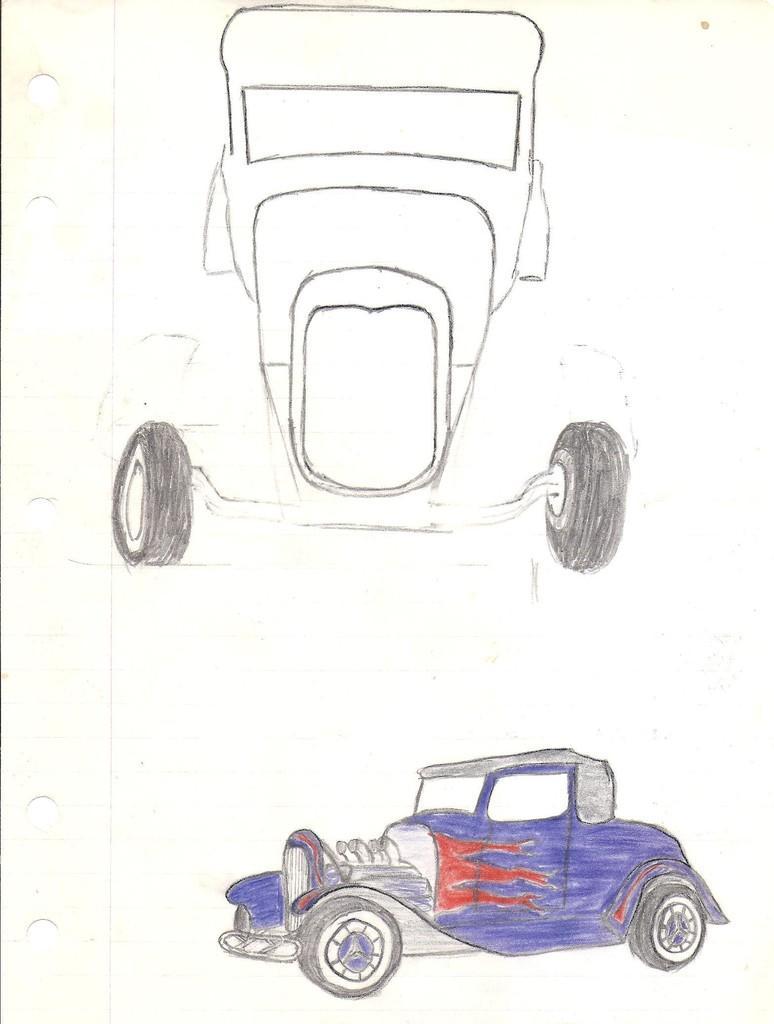Can you describe this image briefly? In the center of the image we can see one paper. On the paper, we can see some drawing, in which we can see vehicles. And we can see some colors on one of the vehicles. 